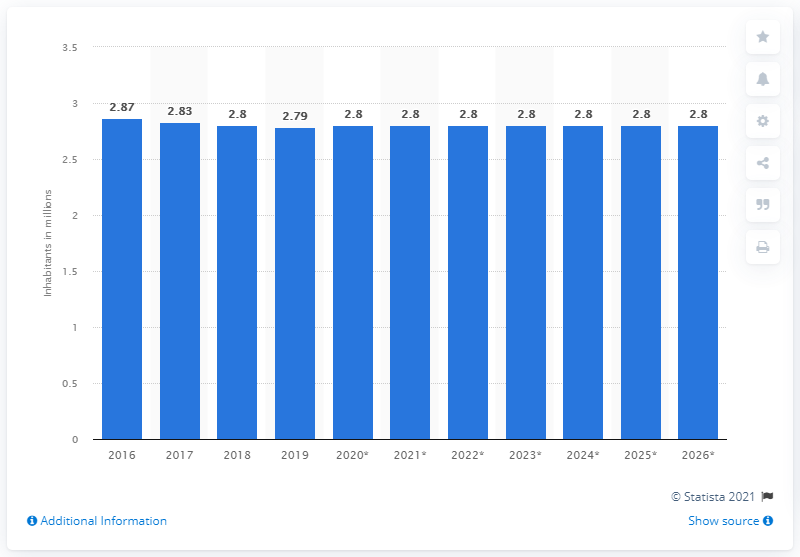List a handful of essential elements in this visual. The population of Lithuania in 2019 was 2.8 million. 